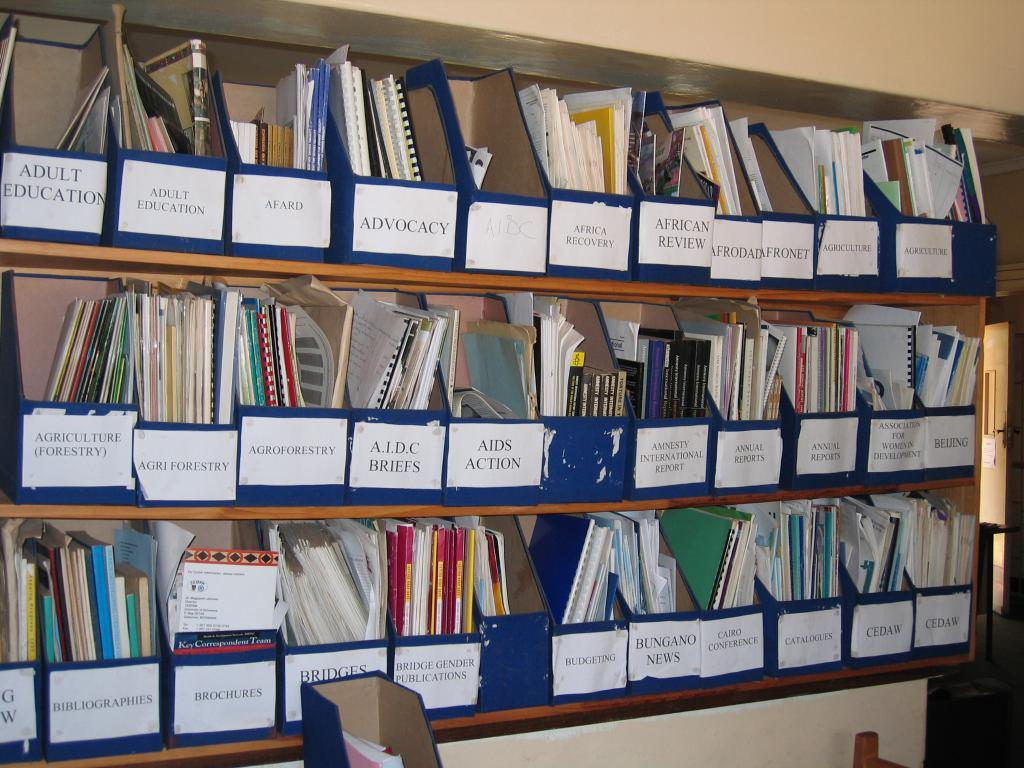<image>
Render a clear and concise summary of the photo. The top left label on the shelf says "Adult Education." 